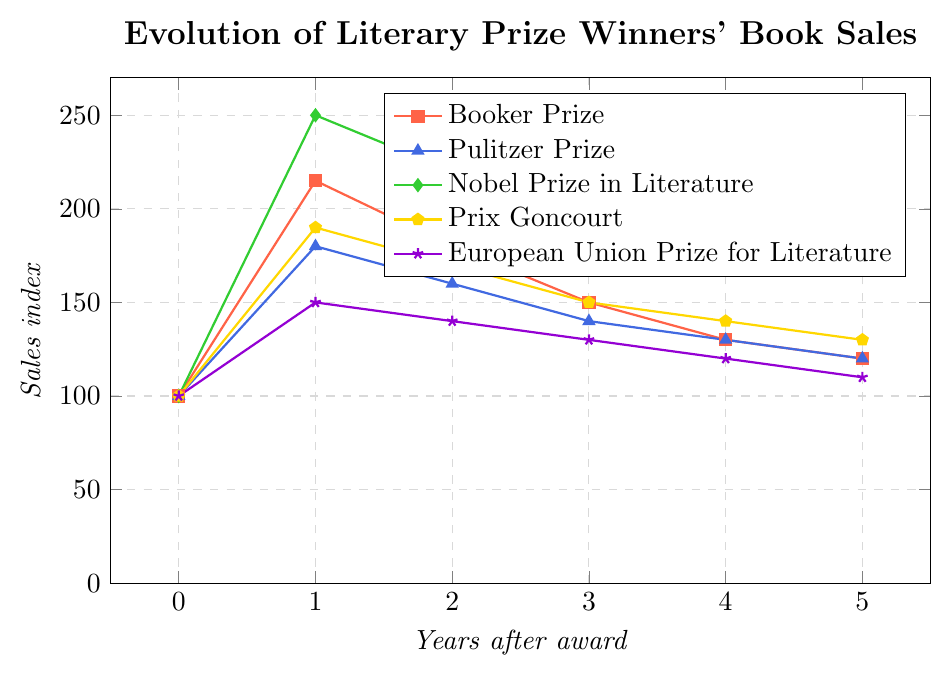what's the overall trend in book sales for Nobel Prize winners over the five years following their award? The sales index starts at 100 in the year of the award, peaks at 250 in the first year after the award, and then sees a steady decline to 170 by the fifth year.
Answer: Decreasing trend Which prize saw the highest sales index at any point in the five years following the award? The Nobel Prize in Literature saw the highest sales index of 250 in the first year after the award.
Answer: Nobel Prize in Literature After five years, which prize's book sales had the lowest sales index? Looking at the sales index at year 5, the European Union Prize for Literature has the lowest index at 110.
Answer: European Union Prize for Literature What is the difference in sales indices between the Booker Prize and the Pulitzer Prize in the year following the award? In the first year, the sales index for the Booker Prize is 215 and for the Pulitzer Prize is 180. The difference is 215 - 180.
Answer: 35 How many years did it take for the sales index of the Nobel Prize to drop below 200? Observing the sales indices for the Nobel Prize across the years, it drops below 200 after 3 years.
Answer: 3 years Compare the sales indices of Booker Prize and Prix Goncourt book sales in the second year after the award. Which one is higher? In the second year, the sales index for the Booker Prize is 180 and for the Prix Goncourt is 170. 180 is higher than 170.
Answer: Booker Prize Which prize had a more significant decline in sales index from the first year to the second year: Booker Prize or Pulitzer Prize? The sales index for the Booker Prize drops from 215 to 180, a decline of 35. The sales index for the Pulitzer Prize drops from 180 to 160, a decline of 20. The Booker Prize had a more significant decline.
Answer: Booker Prize What is the average sales index for the Prix Goncourt over the five years post-award? The sales indices for the Prix Goncourt are (100, 190, 170, 150, 140, 130). The sum is 880, and the average is 880 / 6.
Answer: 146.67 How does the visual representation indicate the overall trend for book sales winning the European Union Prize for Literature? The sales index starts at 100 in the award year and gradually declines to 110 by the fifth year. The declining trend is shown by a consistently downward sloping line.
Answer: Declining trend What is the cumulative sales index for the Pulitzer Prize over the six years, including the year of the award? Summing up the sales indices for the Pulitzer Prize ((100 + 180 + 160 + 140 + 130 + 120)).
Answer: 830 